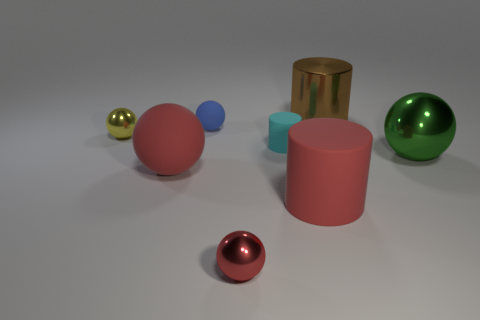Subtract 1 balls. How many balls are left? 4 Subtract all purple balls. Subtract all blue cylinders. How many balls are left? 5 Add 1 big blue objects. How many objects exist? 9 Subtract all cylinders. How many objects are left? 5 Subtract 0 cyan spheres. How many objects are left? 8 Subtract all large red rubber cylinders. Subtract all small cyan matte cylinders. How many objects are left? 6 Add 8 brown shiny things. How many brown shiny things are left? 9 Add 6 big red rubber things. How many big red rubber things exist? 8 